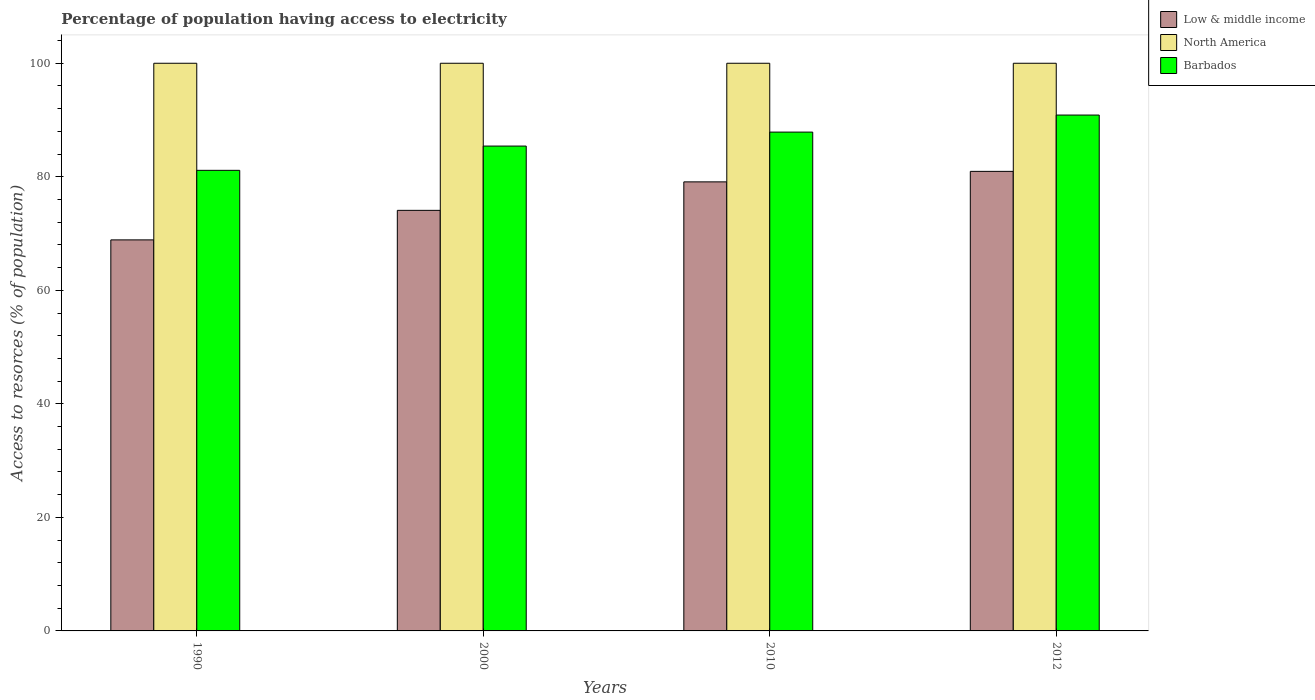How many different coloured bars are there?
Provide a succinct answer. 3. How many groups of bars are there?
Provide a short and direct response. 4. Are the number of bars per tick equal to the number of legend labels?
Ensure brevity in your answer.  Yes. How many bars are there on the 4th tick from the right?
Provide a succinct answer. 3. What is the label of the 3rd group of bars from the left?
Provide a succinct answer. 2010. What is the percentage of population having access to electricity in North America in 1990?
Offer a terse response. 100. Across all years, what is the maximum percentage of population having access to electricity in Barbados?
Provide a short and direct response. 90.88. Across all years, what is the minimum percentage of population having access to electricity in Barbados?
Provide a short and direct response. 81.14. What is the total percentage of population having access to electricity in Low & middle income in the graph?
Your answer should be very brief. 303.03. What is the difference between the percentage of population having access to electricity in Low & middle income in 1990 and that in 2010?
Your answer should be very brief. -10.22. What is the difference between the percentage of population having access to electricity in North America in 2010 and the percentage of population having access to electricity in Barbados in 2012?
Make the answer very short. 9.12. What is the average percentage of population having access to electricity in Low & middle income per year?
Make the answer very short. 75.76. In the year 1990, what is the difference between the percentage of population having access to electricity in Low & middle income and percentage of population having access to electricity in Barbados?
Offer a terse response. -12.25. What is the ratio of the percentage of population having access to electricity in North America in 1990 to that in 2012?
Provide a short and direct response. 1. What is the difference between the highest and the second highest percentage of population having access to electricity in Low & middle income?
Ensure brevity in your answer.  1.85. What is the difference between the highest and the lowest percentage of population having access to electricity in Low & middle income?
Keep it short and to the point. 12.07. In how many years, is the percentage of population having access to electricity in North America greater than the average percentage of population having access to electricity in North America taken over all years?
Offer a very short reply. 0. What does the 1st bar from the left in 1990 represents?
Ensure brevity in your answer.  Low & middle income. How many bars are there?
Keep it short and to the point. 12. What is the difference between two consecutive major ticks on the Y-axis?
Make the answer very short. 20. Are the values on the major ticks of Y-axis written in scientific E-notation?
Keep it short and to the point. No. Does the graph contain any zero values?
Your answer should be compact. No. Does the graph contain grids?
Your answer should be compact. No. How are the legend labels stacked?
Your response must be concise. Vertical. What is the title of the graph?
Ensure brevity in your answer.  Percentage of population having access to electricity. What is the label or title of the X-axis?
Your answer should be very brief. Years. What is the label or title of the Y-axis?
Offer a terse response. Access to resorces (% of population). What is the Access to resorces (% of population) in Low & middle income in 1990?
Your response must be concise. 68.89. What is the Access to resorces (% of population) in Barbados in 1990?
Make the answer very short. 81.14. What is the Access to resorces (% of population) in Low & middle income in 2000?
Your response must be concise. 74.09. What is the Access to resorces (% of population) of North America in 2000?
Your answer should be very brief. 100. What is the Access to resorces (% of population) in Barbados in 2000?
Your answer should be compact. 85.41. What is the Access to resorces (% of population) in Low & middle income in 2010?
Make the answer very short. 79.11. What is the Access to resorces (% of population) in North America in 2010?
Offer a very short reply. 100. What is the Access to resorces (% of population) of Barbados in 2010?
Offer a terse response. 87.87. What is the Access to resorces (% of population) of Low & middle income in 2012?
Offer a very short reply. 80.95. What is the Access to resorces (% of population) in Barbados in 2012?
Offer a terse response. 90.88. Across all years, what is the maximum Access to resorces (% of population) of Low & middle income?
Provide a short and direct response. 80.95. Across all years, what is the maximum Access to resorces (% of population) of Barbados?
Your answer should be compact. 90.88. Across all years, what is the minimum Access to resorces (% of population) of Low & middle income?
Your answer should be very brief. 68.89. Across all years, what is the minimum Access to resorces (% of population) in Barbados?
Your answer should be compact. 81.14. What is the total Access to resorces (% of population) in Low & middle income in the graph?
Keep it short and to the point. 303.03. What is the total Access to resorces (% of population) of Barbados in the graph?
Offer a very short reply. 345.3. What is the difference between the Access to resorces (% of population) in Low & middle income in 1990 and that in 2000?
Your answer should be very brief. -5.2. What is the difference between the Access to resorces (% of population) in North America in 1990 and that in 2000?
Ensure brevity in your answer.  0. What is the difference between the Access to resorces (% of population) in Barbados in 1990 and that in 2000?
Make the answer very short. -4.28. What is the difference between the Access to resorces (% of population) in Low & middle income in 1990 and that in 2010?
Offer a very short reply. -10.22. What is the difference between the Access to resorces (% of population) in Barbados in 1990 and that in 2010?
Give a very brief answer. -6.74. What is the difference between the Access to resorces (% of population) in Low & middle income in 1990 and that in 2012?
Keep it short and to the point. -12.07. What is the difference between the Access to resorces (% of population) in North America in 1990 and that in 2012?
Ensure brevity in your answer.  0. What is the difference between the Access to resorces (% of population) in Barbados in 1990 and that in 2012?
Keep it short and to the point. -9.74. What is the difference between the Access to resorces (% of population) of Low & middle income in 2000 and that in 2010?
Give a very brief answer. -5.02. What is the difference between the Access to resorces (% of population) in North America in 2000 and that in 2010?
Ensure brevity in your answer.  0. What is the difference between the Access to resorces (% of population) in Barbados in 2000 and that in 2010?
Your answer should be compact. -2.46. What is the difference between the Access to resorces (% of population) of Low & middle income in 2000 and that in 2012?
Give a very brief answer. -6.87. What is the difference between the Access to resorces (% of population) of North America in 2000 and that in 2012?
Make the answer very short. 0. What is the difference between the Access to resorces (% of population) of Barbados in 2000 and that in 2012?
Provide a succinct answer. -5.46. What is the difference between the Access to resorces (% of population) of Low & middle income in 2010 and that in 2012?
Ensure brevity in your answer.  -1.85. What is the difference between the Access to resorces (% of population) of North America in 2010 and that in 2012?
Offer a terse response. 0. What is the difference between the Access to resorces (% of population) in Barbados in 2010 and that in 2012?
Offer a terse response. -3. What is the difference between the Access to resorces (% of population) in Low & middle income in 1990 and the Access to resorces (% of population) in North America in 2000?
Ensure brevity in your answer.  -31.11. What is the difference between the Access to resorces (% of population) in Low & middle income in 1990 and the Access to resorces (% of population) in Barbados in 2000?
Your answer should be compact. -16.53. What is the difference between the Access to resorces (% of population) in North America in 1990 and the Access to resorces (% of population) in Barbados in 2000?
Make the answer very short. 14.59. What is the difference between the Access to resorces (% of population) of Low & middle income in 1990 and the Access to resorces (% of population) of North America in 2010?
Offer a terse response. -31.11. What is the difference between the Access to resorces (% of population) of Low & middle income in 1990 and the Access to resorces (% of population) of Barbados in 2010?
Offer a terse response. -18.99. What is the difference between the Access to resorces (% of population) of North America in 1990 and the Access to resorces (% of population) of Barbados in 2010?
Give a very brief answer. 12.13. What is the difference between the Access to resorces (% of population) in Low & middle income in 1990 and the Access to resorces (% of population) in North America in 2012?
Make the answer very short. -31.11. What is the difference between the Access to resorces (% of population) in Low & middle income in 1990 and the Access to resorces (% of population) in Barbados in 2012?
Offer a very short reply. -21.99. What is the difference between the Access to resorces (% of population) in North America in 1990 and the Access to resorces (% of population) in Barbados in 2012?
Provide a succinct answer. 9.12. What is the difference between the Access to resorces (% of population) in Low & middle income in 2000 and the Access to resorces (% of population) in North America in 2010?
Offer a very short reply. -25.91. What is the difference between the Access to resorces (% of population) of Low & middle income in 2000 and the Access to resorces (% of population) of Barbados in 2010?
Keep it short and to the point. -13.78. What is the difference between the Access to resorces (% of population) of North America in 2000 and the Access to resorces (% of population) of Barbados in 2010?
Offer a very short reply. 12.13. What is the difference between the Access to resorces (% of population) in Low & middle income in 2000 and the Access to resorces (% of population) in North America in 2012?
Your answer should be compact. -25.91. What is the difference between the Access to resorces (% of population) of Low & middle income in 2000 and the Access to resorces (% of population) of Barbados in 2012?
Your answer should be compact. -16.79. What is the difference between the Access to resorces (% of population) of North America in 2000 and the Access to resorces (% of population) of Barbados in 2012?
Keep it short and to the point. 9.12. What is the difference between the Access to resorces (% of population) of Low & middle income in 2010 and the Access to resorces (% of population) of North America in 2012?
Your response must be concise. -20.89. What is the difference between the Access to resorces (% of population) in Low & middle income in 2010 and the Access to resorces (% of population) in Barbados in 2012?
Provide a succinct answer. -11.77. What is the difference between the Access to resorces (% of population) in North America in 2010 and the Access to resorces (% of population) in Barbados in 2012?
Keep it short and to the point. 9.12. What is the average Access to resorces (% of population) of Low & middle income per year?
Your answer should be very brief. 75.76. What is the average Access to resorces (% of population) of North America per year?
Give a very brief answer. 100. What is the average Access to resorces (% of population) of Barbados per year?
Your answer should be compact. 86.32. In the year 1990, what is the difference between the Access to resorces (% of population) in Low & middle income and Access to resorces (% of population) in North America?
Your answer should be very brief. -31.11. In the year 1990, what is the difference between the Access to resorces (% of population) of Low & middle income and Access to resorces (% of population) of Barbados?
Ensure brevity in your answer.  -12.25. In the year 1990, what is the difference between the Access to resorces (% of population) of North America and Access to resorces (% of population) of Barbados?
Give a very brief answer. 18.86. In the year 2000, what is the difference between the Access to resorces (% of population) in Low & middle income and Access to resorces (% of population) in North America?
Provide a succinct answer. -25.91. In the year 2000, what is the difference between the Access to resorces (% of population) in Low & middle income and Access to resorces (% of population) in Barbados?
Give a very brief answer. -11.32. In the year 2000, what is the difference between the Access to resorces (% of population) in North America and Access to resorces (% of population) in Barbados?
Offer a very short reply. 14.59. In the year 2010, what is the difference between the Access to resorces (% of population) of Low & middle income and Access to resorces (% of population) of North America?
Keep it short and to the point. -20.89. In the year 2010, what is the difference between the Access to resorces (% of population) in Low & middle income and Access to resorces (% of population) in Barbados?
Offer a very short reply. -8.77. In the year 2010, what is the difference between the Access to resorces (% of population) of North America and Access to resorces (% of population) of Barbados?
Your answer should be very brief. 12.13. In the year 2012, what is the difference between the Access to resorces (% of population) of Low & middle income and Access to resorces (% of population) of North America?
Provide a short and direct response. -19.05. In the year 2012, what is the difference between the Access to resorces (% of population) of Low & middle income and Access to resorces (% of population) of Barbados?
Your answer should be very brief. -9.92. In the year 2012, what is the difference between the Access to resorces (% of population) of North America and Access to resorces (% of population) of Barbados?
Offer a very short reply. 9.12. What is the ratio of the Access to resorces (% of population) in Low & middle income in 1990 to that in 2000?
Provide a succinct answer. 0.93. What is the ratio of the Access to resorces (% of population) of North America in 1990 to that in 2000?
Give a very brief answer. 1. What is the ratio of the Access to resorces (% of population) in Barbados in 1990 to that in 2000?
Ensure brevity in your answer.  0.95. What is the ratio of the Access to resorces (% of population) in Low & middle income in 1990 to that in 2010?
Your answer should be very brief. 0.87. What is the ratio of the Access to resorces (% of population) in North America in 1990 to that in 2010?
Give a very brief answer. 1. What is the ratio of the Access to resorces (% of population) in Barbados in 1990 to that in 2010?
Your answer should be compact. 0.92. What is the ratio of the Access to resorces (% of population) in Low & middle income in 1990 to that in 2012?
Give a very brief answer. 0.85. What is the ratio of the Access to resorces (% of population) in Barbados in 1990 to that in 2012?
Your answer should be compact. 0.89. What is the ratio of the Access to resorces (% of population) of Low & middle income in 2000 to that in 2010?
Your response must be concise. 0.94. What is the ratio of the Access to resorces (% of population) in North America in 2000 to that in 2010?
Provide a succinct answer. 1. What is the ratio of the Access to resorces (% of population) in Low & middle income in 2000 to that in 2012?
Your answer should be very brief. 0.92. What is the ratio of the Access to resorces (% of population) in North America in 2000 to that in 2012?
Your answer should be compact. 1. What is the ratio of the Access to resorces (% of population) of Barbados in 2000 to that in 2012?
Provide a succinct answer. 0.94. What is the ratio of the Access to resorces (% of population) in Low & middle income in 2010 to that in 2012?
Make the answer very short. 0.98. What is the ratio of the Access to resorces (% of population) in North America in 2010 to that in 2012?
Keep it short and to the point. 1. What is the difference between the highest and the second highest Access to resorces (% of population) in Low & middle income?
Keep it short and to the point. 1.85. What is the difference between the highest and the second highest Access to resorces (% of population) in Barbados?
Make the answer very short. 3. What is the difference between the highest and the lowest Access to resorces (% of population) of Low & middle income?
Your answer should be compact. 12.07. What is the difference between the highest and the lowest Access to resorces (% of population) in Barbados?
Your response must be concise. 9.74. 